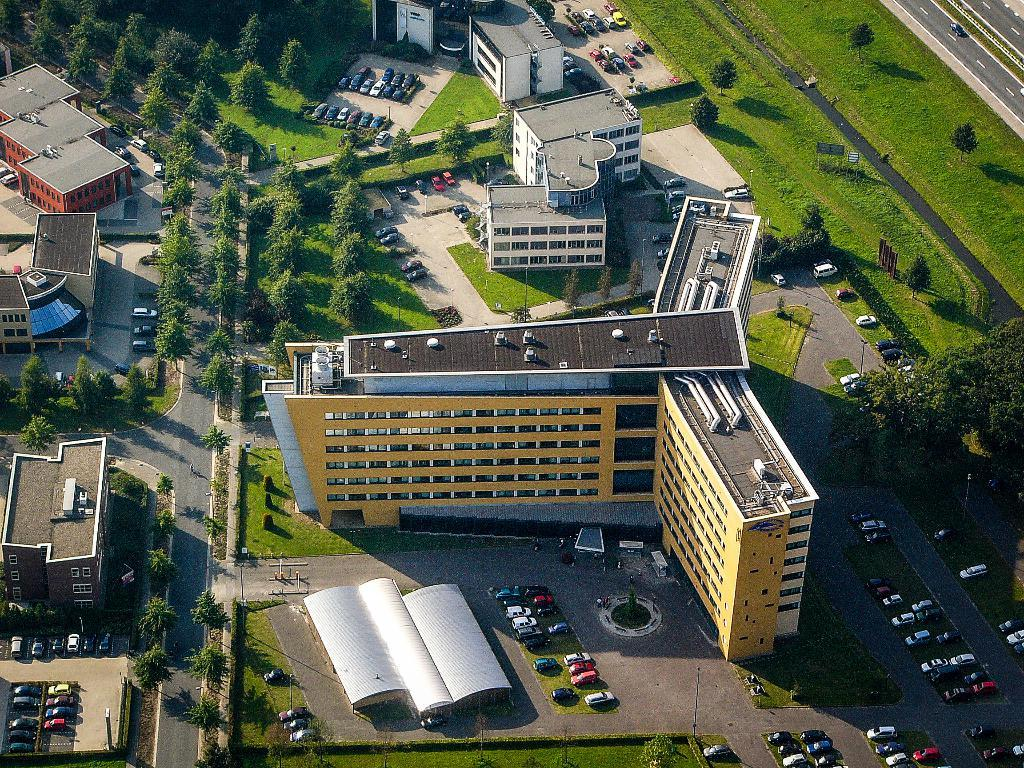What is the perspective of the image? The image is taken from a top view. What type of natural elements can be seen in the image? There are trees and grass visible in the image. What type of man-made structures are present in the image? There are buildings and poles in the image. What type of transportation infrastructure is visible in the image? There is a road in the image, and a car is moving on it. What type of vehicles are parked in the image? New vehicles are parked in the image. How many branches are hanging from the trees in the image? There is no information about the number of branches hanging from the trees in the image. What type of cart is being pulled by the rainstorm in the image? There is no rainstorm or cart present in the image. 